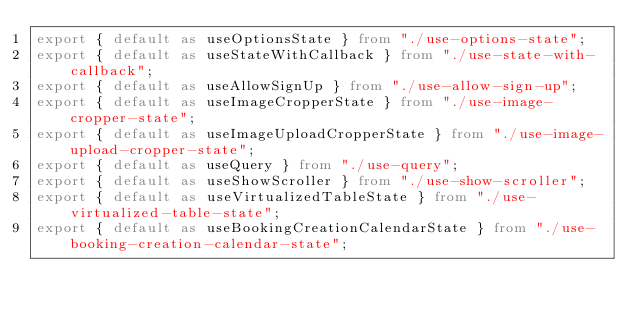<code> <loc_0><loc_0><loc_500><loc_500><_TypeScript_>export { default as useOptionsState } from "./use-options-state";
export { default as useStateWithCallback } from "./use-state-with-callback";
export { default as useAllowSignUp } from "./use-allow-sign-up";
export { default as useImageCropperState } from "./use-image-cropper-state";
export { default as useImageUploadCropperState } from "./use-image-upload-cropper-state";
export { default as useQuery } from "./use-query";
export { default as useShowScroller } from "./use-show-scroller";
export { default as useVirtualizedTableState } from "./use-virtualized-table-state";
export { default as useBookingCreationCalendarState } from "./use-booking-creation-calendar-state";
</code> 